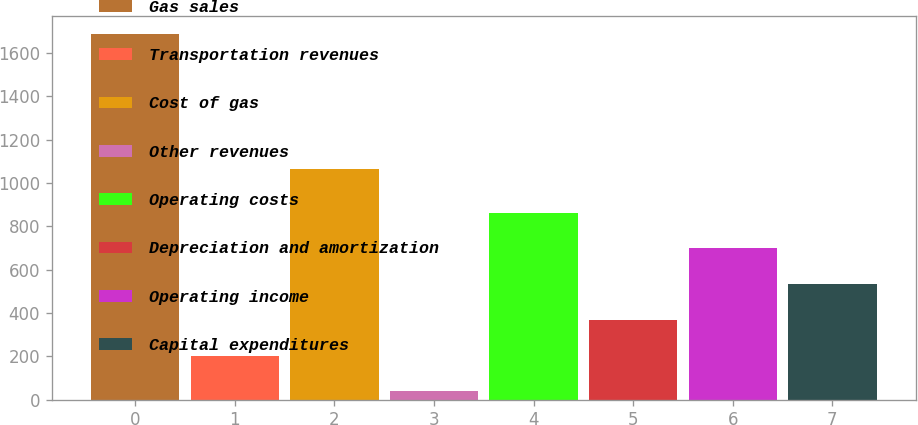<chart> <loc_0><loc_0><loc_500><loc_500><bar_chart><fcel>Gas sales<fcel>Transportation revenues<fcel>Cost of gas<fcel>Other revenues<fcel>Operating costs<fcel>Depreciation and amortization<fcel>Operating income<fcel>Capital expenditures<nl><fcel>1687.4<fcel>203.39<fcel>1062.5<fcel>38.5<fcel>862.95<fcel>368.28<fcel>698.06<fcel>533.17<nl></chart> 